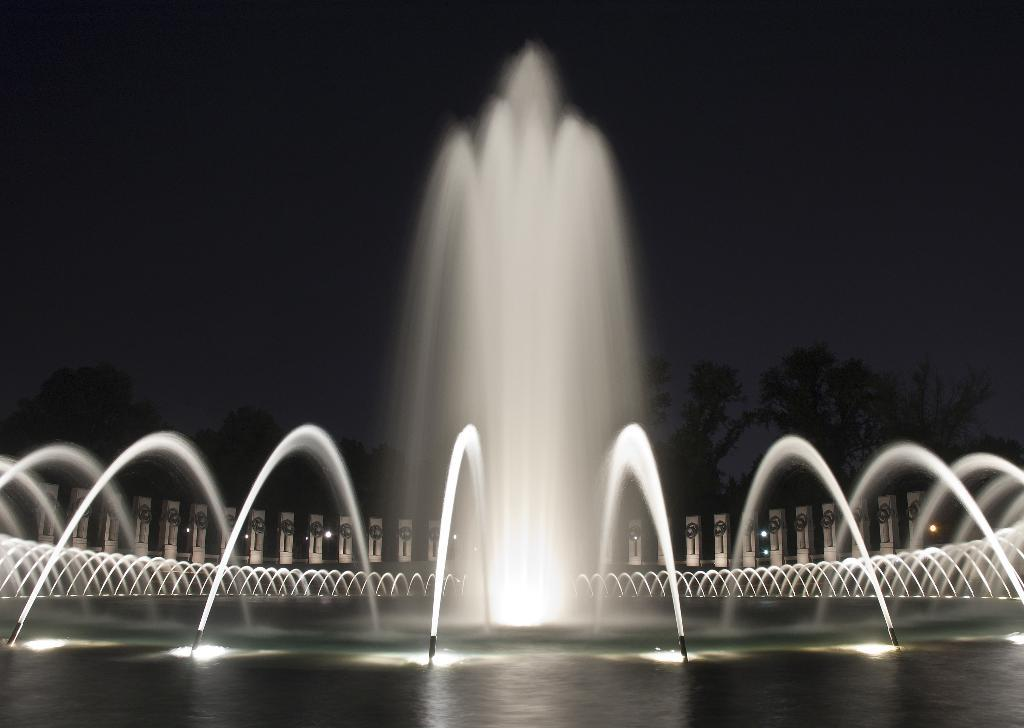What is the main feature in the image? There is a fountain in the image. What is flowing from the fountain? Water is visible in the image, flowing from the fountain. What type of structure can be seen in the image? There is a building in the image. What type of natural elements are present in the image? There are many trees in the image. What is visible in the background of the image? The sky is visible in the image. Can you see a minister flying a kite in the amusement park in the image? There is no amusement park, minister, or kite present in the image. 